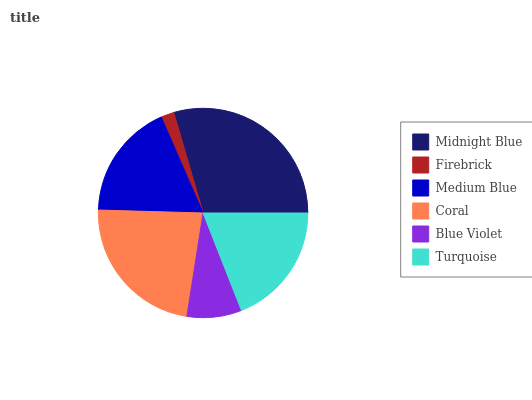Is Firebrick the minimum?
Answer yes or no. Yes. Is Midnight Blue the maximum?
Answer yes or no. Yes. Is Medium Blue the minimum?
Answer yes or no. No. Is Medium Blue the maximum?
Answer yes or no. No. Is Medium Blue greater than Firebrick?
Answer yes or no. Yes. Is Firebrick less than Medium Blue?
Answer yes or no. Yes. Is Firebrick greater than Medium Blue?
Answer yes or no. No. Is Medium Blue less than Firebrick?
Answer yes or no. No. Is Turquoise the high median?
Answer yes or no. Yes. Is Medium Blue the low median?
Answer yes or no. Yes. Is Blue Violet the high median?
Answer yes or no. No. Is Firebrick the low median?
Answer yes or no. No. 